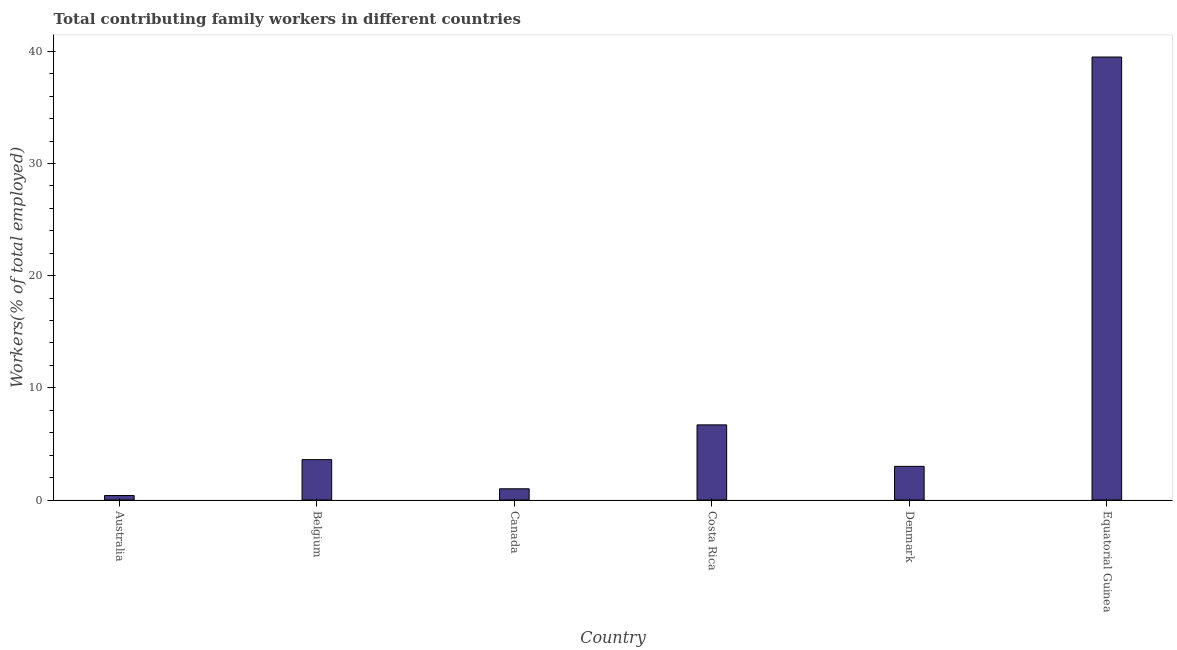What is the title of the graph?
Your answer should be very brief. Total contributing family workers in different countries. What is the label or title of the X-axis?
Your answer should be very brief. Country. What is the label or title of the Y-axis?
Your response must be concise. Workers(% of total employed). What is the contributing family workers in Equatorial Guinea?
Offer a terse response. 39.5. Across all countries, what is the maximum contributing family workers?
Provide a succinct answer. 39.5. Across all countries, what is the minimum contributing family workers?
Provide a succinct answer. 0.4. In which country was the contributing family workers maximum?
Provide a short and direct response. Equatorial Guinea. In which country was the contributing family workers minimum?
Offer a very short reply. Australia. What is the sum of the contributing family workers?
Ensure brevity in your answer.  54.2. What is the difference between the contributing family workers in Australia and Equatorial Guinea?
Give a very brief answer. -39.1. What is the average contributing family workers per country?
Your answer should be compact. 9.03. What is the median contributing family workers?
Offer a very short reply. 3.3. In how many countries, is the contributing family workers greater than 38 %?
Your response must be concise. 1. What is the ratio of the contributing family workers in Costa Rica to that in Equatorial Guinea?
Provide a succinct answer. 0.17. Is the contributing family workers in Denmark less than that in Equatorial Guinea?
Keep it short and to the point. Yes. Is the difference between the contributing family workers in Costa Rica and Denmark greater than the difference between any two countries?
Offer a very short reply. No. What is the difference between the highest and the second highest contributing family workers?
Give a very brief answer. 32.8. What is the difference between the highest and the lowest contributing family workers?
Keep it short and to the point. 39.1. How many bars are there?
Offer a terse response. 6. What is the Workers(% of total employed) in Australia?
Your answer should be compact. 0.4. What is the Workers(% of total employed) of Belgium?
Make the answer very short. 3.6. What is the Workers(% of total employed) in Costa Rica?
Your answer should be very brief. 6.7. What is the Workers(% of total employed) in Denmark?
Your answer should be very brief. 3. What is the Workers(% of total employed) in Equatorial Guinea?
Make the answer very short. 39.5. What is the difference between the Workers(% of total employed) in Australia and Belgium?
Your answer should be compact. -3.2. What is the difference between the Workers(% of total employed) in Australia and Canada?
Keep it short and to the point. -0.6. What is the difference between the Workers(% of total employed) in Australia and Costa Rica?
Your answer should be very brief. -6.3. What is the difference between the Workers(% of total employed) in Australia and Equatorial Guinea?
Provide a succinct answer. -39.1. What is the difference between the Workers(% of total employed) in Belgium and Canada?
Ensure brevity in your answer.  2.6. What is the difference between the Workers(% of total employed) in Belgium and Denmark?
Give a very brief answer. 0.6. What is the difference between the Workers(% of total employed) in Belgium and Equatorial Guinea?
Give a very brief answer. -35.9. What is the difference between the Workers(% of total employed) in Canada and Costa Rica?
Keep it short and to the point. -5.7. What is the difference between the Workers(% of total employed) in Canada and Equatorial Guinea?
Your response must be concise. -38.5. What is the difference between the Workers(% of total employed) in Costa Rica and Denmark?
Your answer should be very brief. 3.7. What is the difference between the Workers(% of total employed) in Costa Rica and Equatorial Guinea?
Your answer should be very brief. -32.8. What is the difference between the Workers(% of total employed) in Denmark and Equatorial Guinea?
Ensure brevity in your answer.  -36.5. What is the ratio of the Workers(% of total employed) in Australia to that in Belgium?
Keep it short and to the point. 0.11. What is the ratio of the Workers(% of total employed) in Australia to that in Costa Rica?
Provide a short and direct response. 0.06. What is the ratio of the Workers(% of total employed) in Australia to that in Denmark?
Offer a very short reply. 0.13. What is the ratio of the Workers(% of total employed) in Australia to that in Equatorial Guinea?
Offer a very short reply. 0.01. What is the ratio of the Workers(% of total employed) in Belgium to that in Costa Rica?
Offer a very short reply. 0.54. What is the ratio of the Workers(% of total employed) in Belgium to that in Denmark?
Offer a terse response. 1.2. What is the ratio of the Workers(% of total employed) in Belgium to that in Equatorial Guinea?
Ensure brevity in your answer.  0.09. What is the ratio of the Workers(% of total employed) in Canada to that in Costa Rica?
Your response must be concise. 0.15. What is the ratio of the Workers(% of total employed) in Canada to that in Denmark?
Provide a succinct answer. 0.33. What is the ratio of the Workers(% of total employed) in Canada to that in Equatorial Guinea?
Ensure brevity in your answer.  0.03. What is the ratio of the Workers(% of total employed) in Costa Rica to that in Denmark?
Offer a terse response. 2.23. What is the ratio of the Workers(% of total employed) in Costa Rica to that in Equatorial Guinea?
Provide a succinct answer. 0.17. What is the ratio of the Workers(% of total employed) in Denmark to that in Equatorial Guinea?
Ensure brevity in your answer.  0.08. 